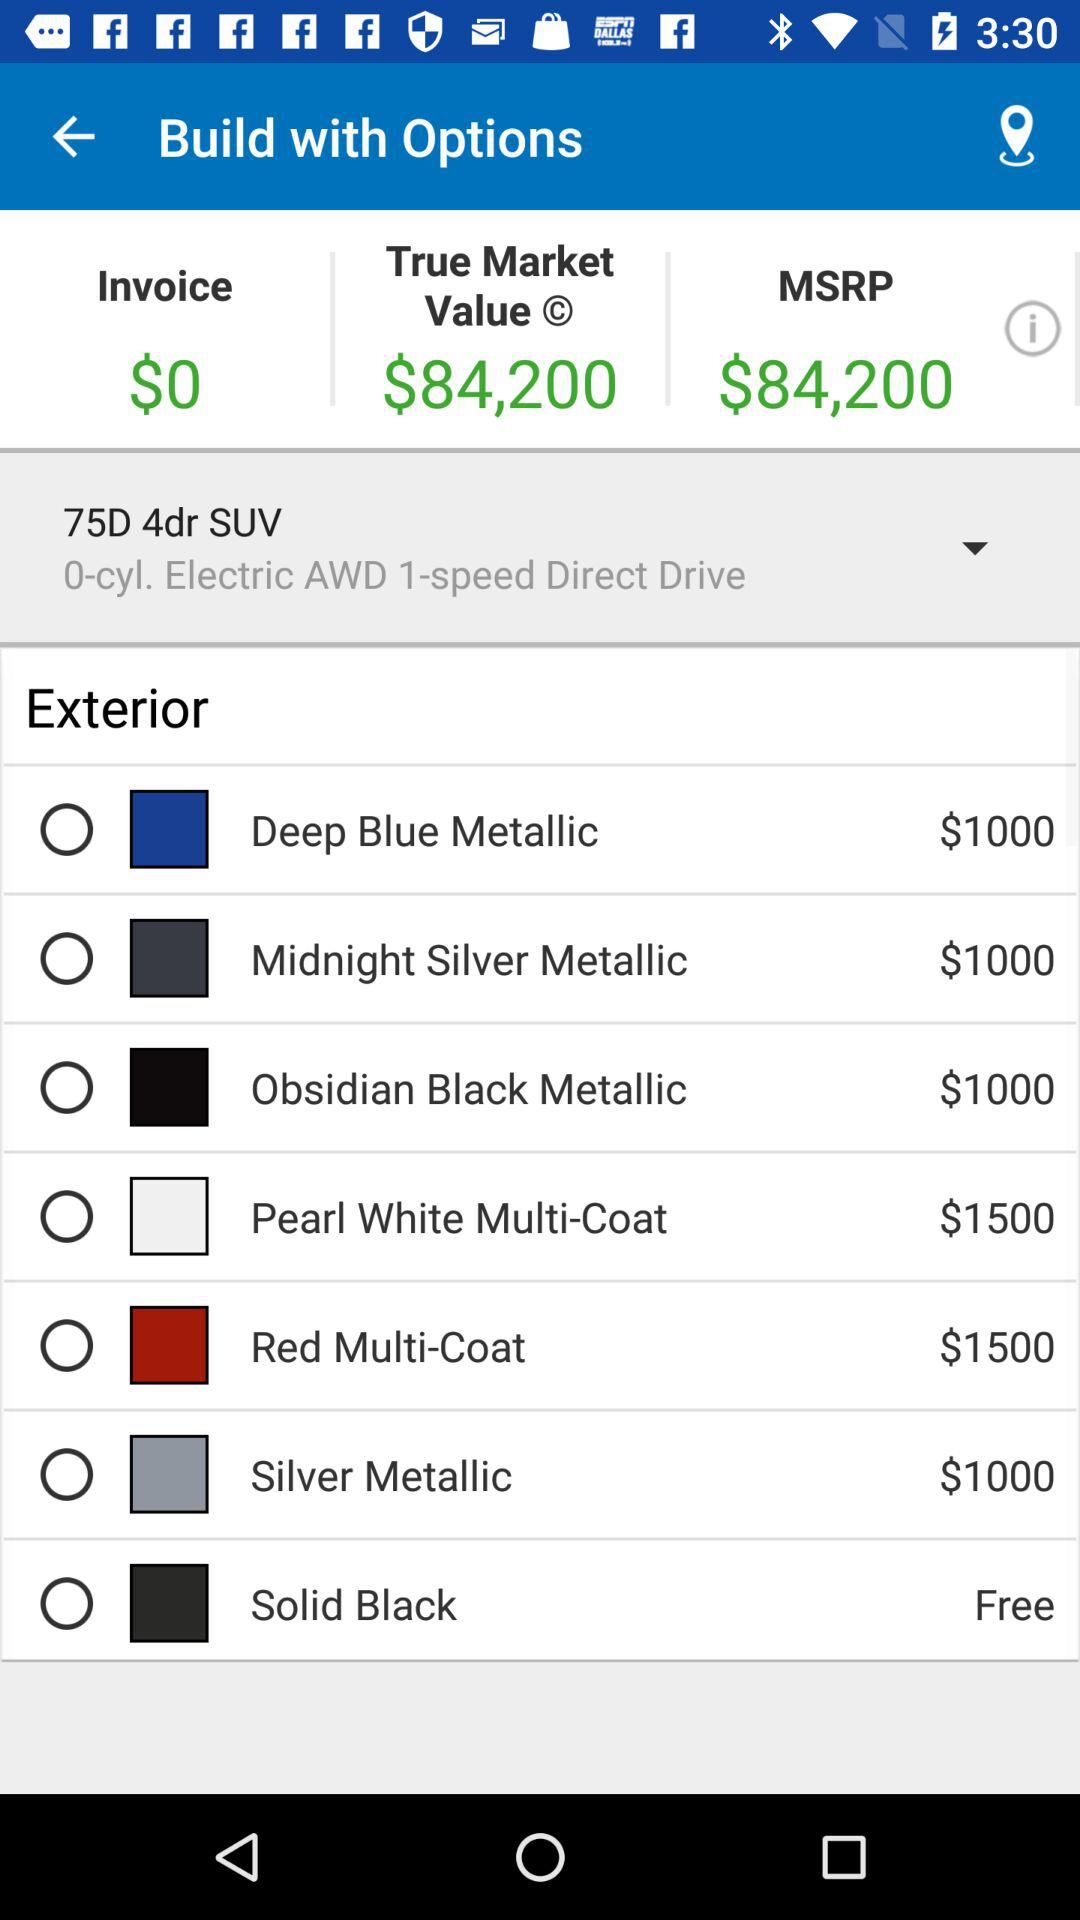What is the MSRP? The MSRP is $84,200. 